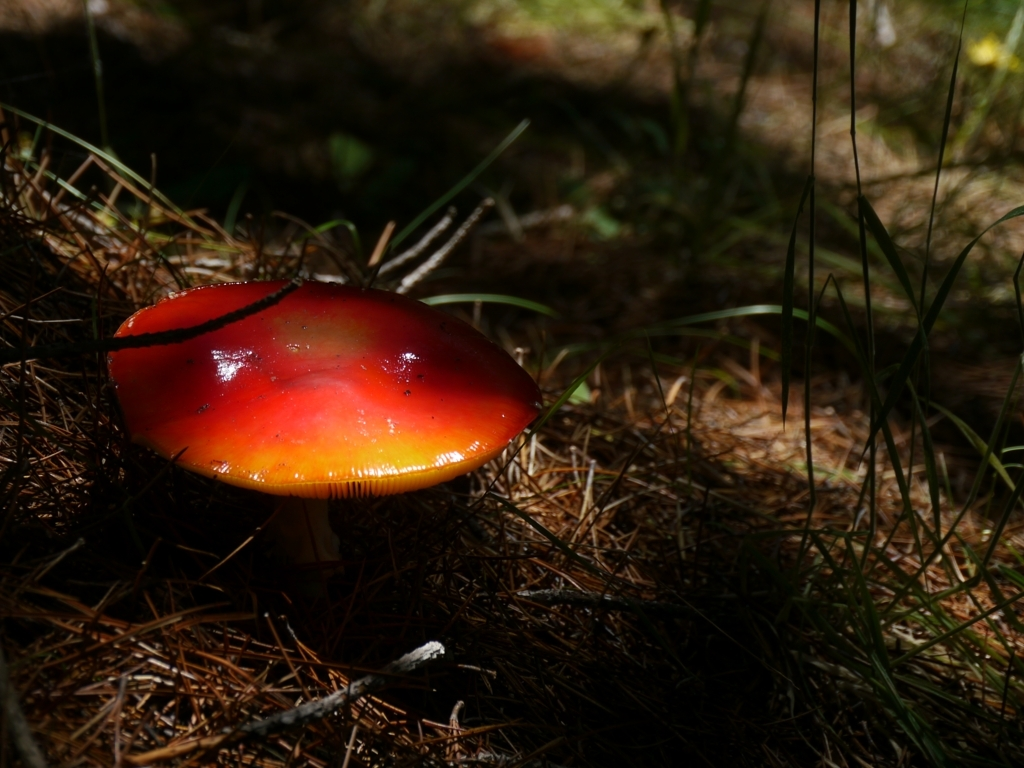How is the color contrast between the subject and the background?
 strong 